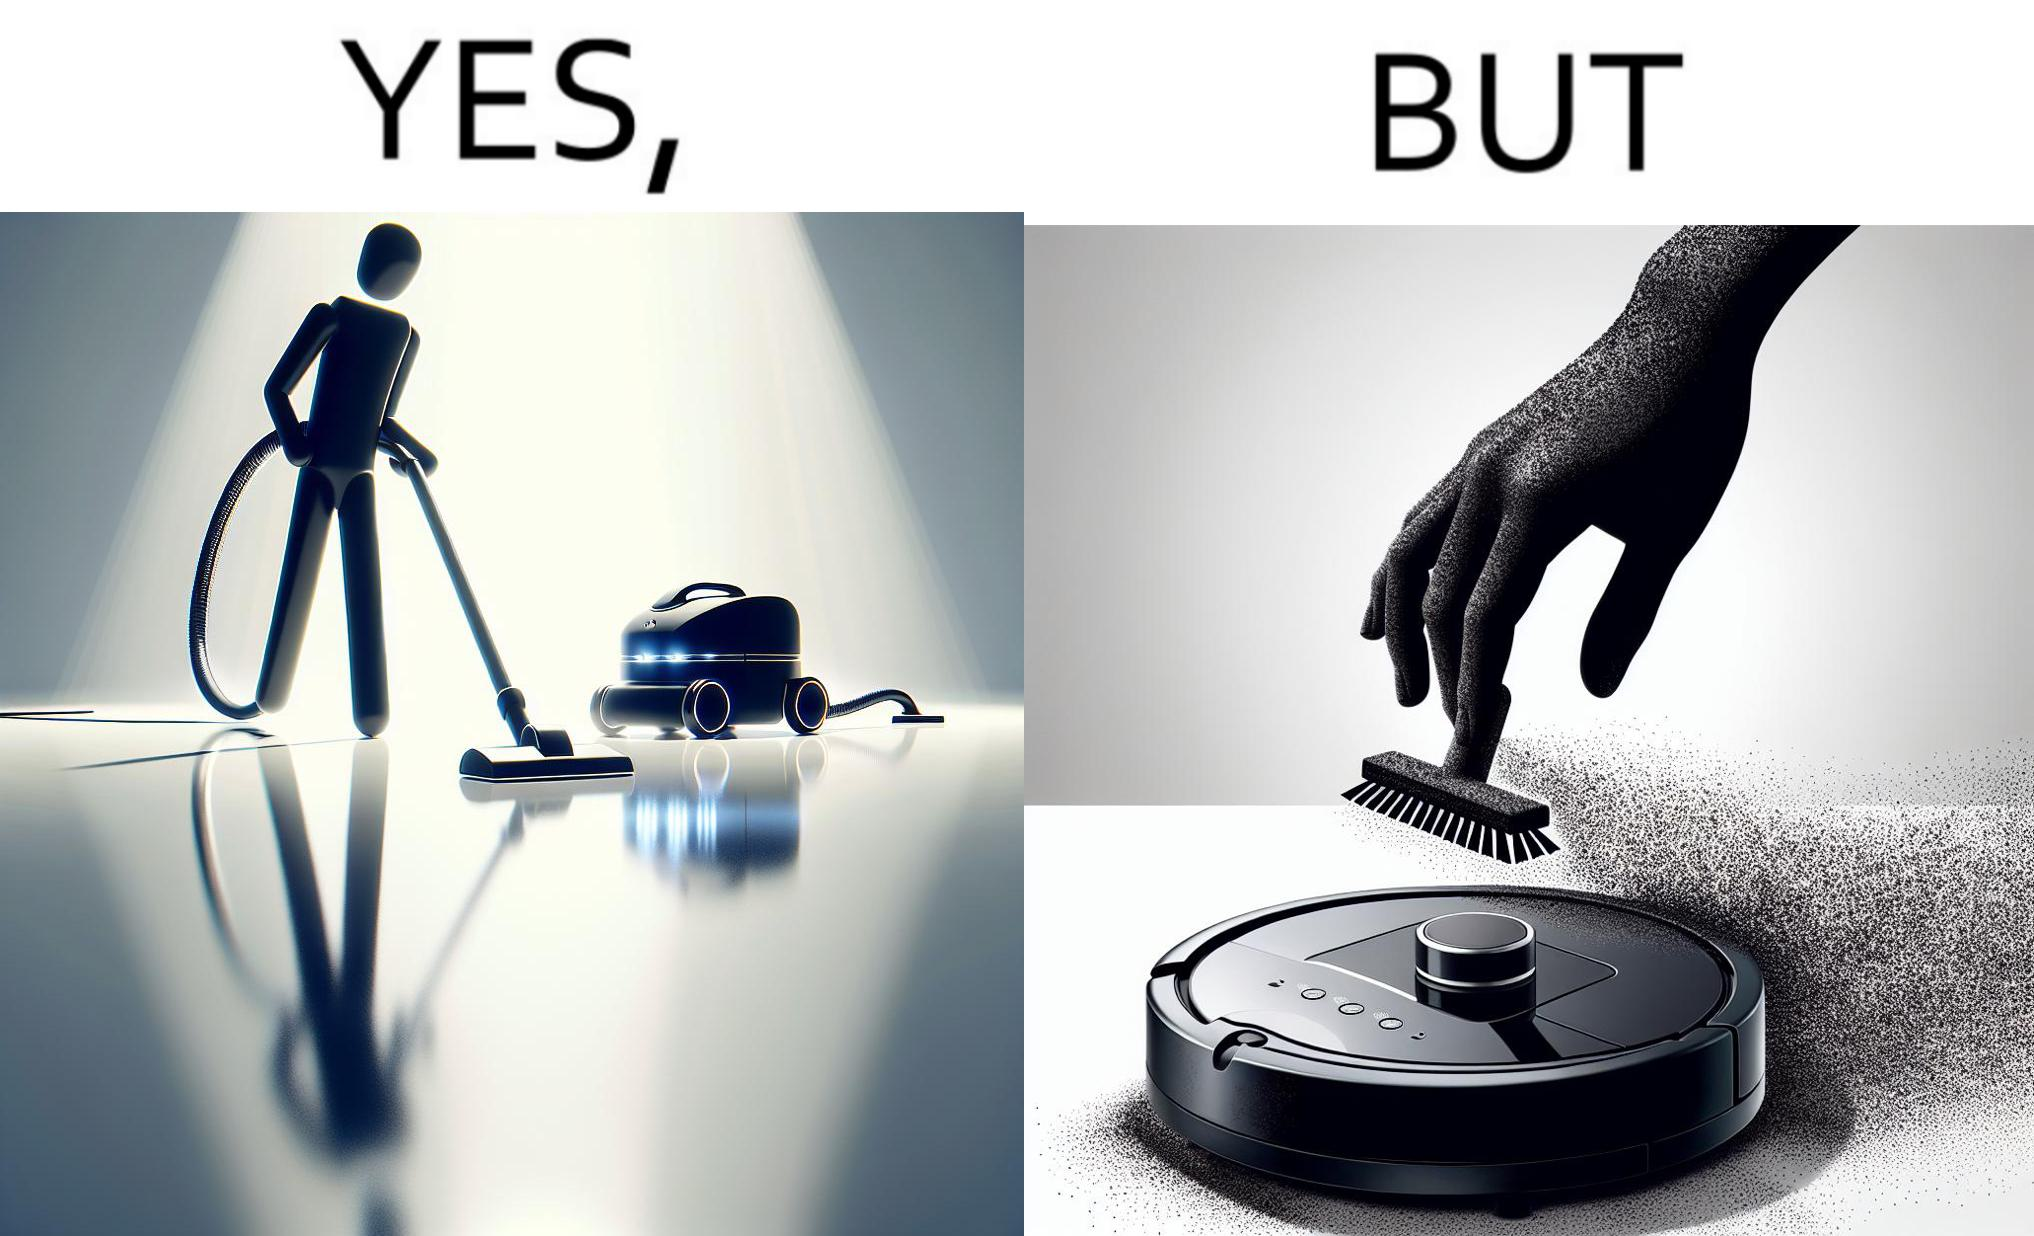Why is this image considered satirical? This is funny, because the machine while doing its job cleans everything but ends up being dirty itself. 